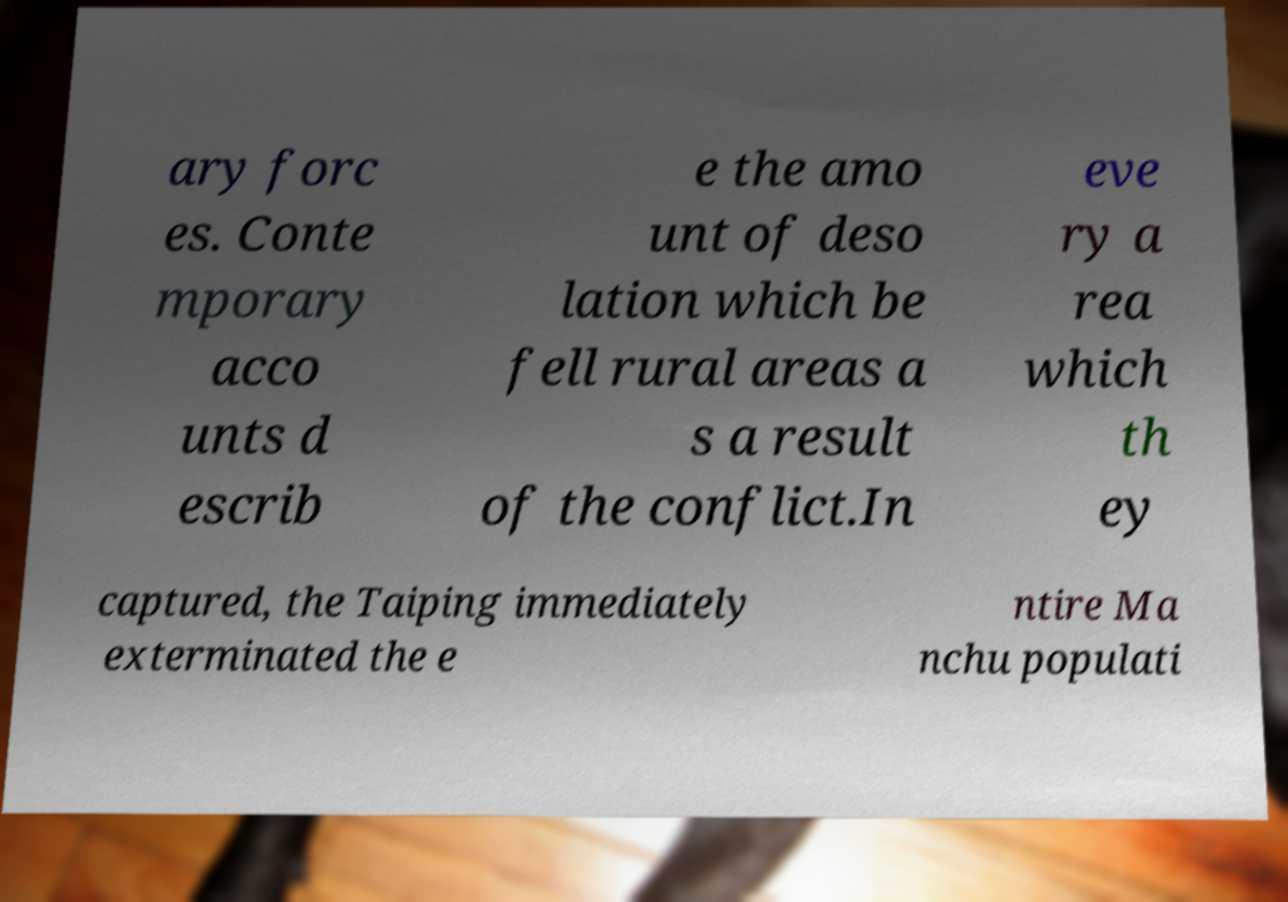Please identify and transcribe the text found in this image. ary forc es. Conte mporary acco unts d escrib e the amo unt of deso lation which be fell rural areas a s a result of the conflict.In eve ry a rea which th ey captured, the Taiping immediately exterminated the e ntire Ma nchu populati 